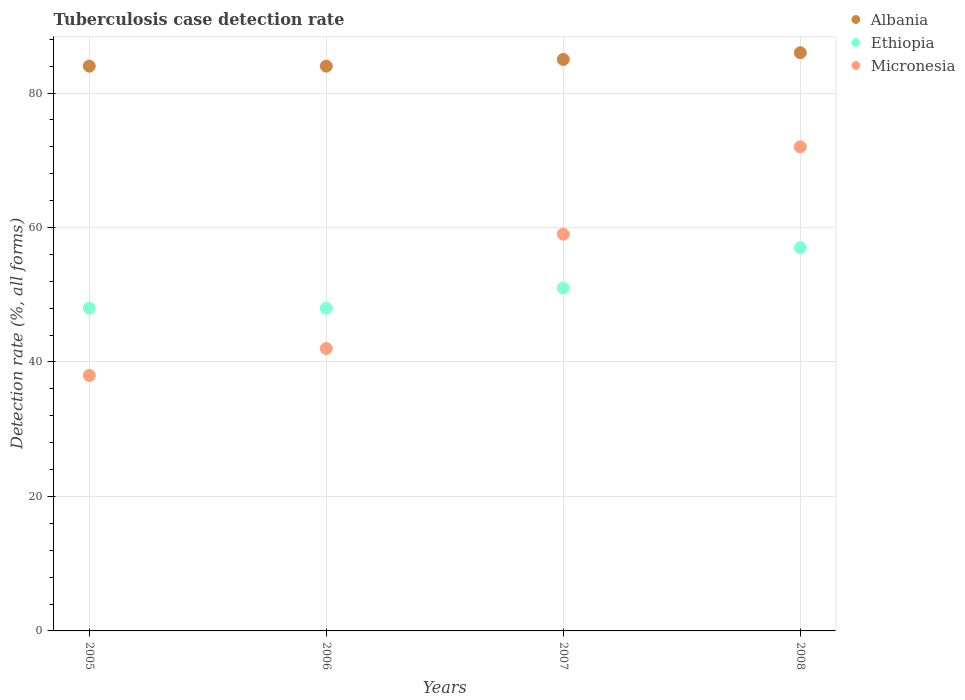What is the tuberculosis case detection rate in in Ethiopia in 2007?
Keep it short and to the point. 51. Across all years, what is the maximum tuberculosis case detection rate in in Albania?
Keep it short and to the point. 86. Across all years, what is the minimum tuberculosis case detection rate in in Ethiopia?
Your answer should be very brief. 48. In which year was the tuberculosis case detection rate in in Albania maximum?
Offer a very short reply. 2008. What is the total tuberculosis case detection rate in in Ethiopia in the graph?
Offer a very short reply. 204. What is the difference between the tuberculosis case detection rate in in Albania in 2007 and that in 2008?
Offer a terse response. -1. What is the difference between the tuberculosis case detection rate in in Micronesia in 2006 and the tuberculosis case detection rate in in Ethiopia in 2005?
Offer a terse response. -6. What is the average tuberculosis case detection rate in in Micronesia per year?
Ensure brevity in your answer.  52.75. In the year 2006, what is the difference between the tuberculosis case detection rate in in Albania and tuberculosis case detection rate in in Ethiopia?
Your answer should be compact. 36. What is the ratio of the tuberculosis case detection rate in in Ethiopia in 2005 to that in 2008?
Your response must be concise. 0.84. Is the tuberculosis case detection rate in in Micronesia in 2005 less than that in 2007?
Make the answer very short. Yes. Is the sum of the tuberculosis case detection rate in in Albania in 2005 and 2007 greater than the maximum tuberculosis case detection rate in in Micronesia across all years?
Provide a short and direct response. Yes. Is the tuberculosis case detection rate in in Albania strictly less than the tuberculosis case detection rate in in Ethiopia over the years?
Give a very brief answer. No. How many dotlines are there?
Your response must be concise. 3. How many years are there in the graph?
Keep it short and to the point. 4. Does the graph contain any zero values?
Provide a succinct answer. No. Where does the legend appear in the graph?
Your answer should be compact. Top right. How many legend labels are there?
Give a very brief answer. 3. How are the legend labels stacked?
Offer a terse response. Vertical. What is the title of the graph?
Make the answer very short. Tuberculosis case detection rate. What is the label or title of the X-axis?
Provide a succinct answer. Years. What is the label or title of the Y-axis?
Ensure brevity in your answer.  Detection rate (%, all forms). What is the Detection rate (%, all forms) in Albania in 2005?
Provide a succinct answer. 84. What is the Detection rate (%, all forms) in Albania in 2006?
Your answer should be compact. 84. What is the Detection rate (%, all forms) in Ethiopia in 2006?
Offer a very short reply. 48. What is the Detection rate (%, all forms) of Albania in 2007?
Give a very brief answer. 85. What is the Detection rate (%, all forms) in Albania in 2008?
Provide a succinct answer. 86. What is the Detection rate (%, all forms) of Micronesia in 2008?
Make the answer very short. 72. Across all years, what is the maximum Detection rate (%, all forms) in Albania?
Provide a succinct answer. 86. Across all years, what is the maximum Detection rate (%, all forms) in Ethiopia?
Give a very brief answer. 57. Across all years, what is the maximum Detection rate (%, all forms) of Micronesia?
Provide a succinct answer. 72. Across all years, what is the minimum Detection rate (%, all forms) in Ethiopia?
Give a very brief answer. 48. Across all years, what is the minimum Detection rate (%, all forms) in Micronesia?
Provide a succinct answer. 38. What is the total Detection rate (%, all forms) of Albania in the graph?
Your answer should be compact. 339. What is the total Detection rate (%, all forms) in Ethiopia in the graph?
Your response must be concise. 204. What is the total Detection rate (%, all forms) of Micronesia in the graph?
Your answer should be very brief. 211. What is the difference between the Detection rate (%, all forms) of Ethiopia in 2005 and that in 2006?
Offer a terse response. 0. What is the difference between the Detection rate (%, all forms) in Albania in 2005 and that in 2007?
Offer a terse response. -1. What is the difference between the Detection rate (%, all forms) in Ethiopia in 2005 and that in 2007?
Give a very brief answer. -3. What is the difference between the Detection rate (%, all forms) in Micronesia in 2005 and that in 2007?
Give a very brief answer. -21. What is the difference between the Detection rate (%, all forms) in Albania in 2005 and that in 2008?
Provide a succinct answer. -2. What is the difference between the Detection rate (%, all forms) of Micronesia in 2005 and that in 2008?
Make the answer very short. -34. What is the difference between the Detection rate (%, all forms) of Ethiopia in 2006 and that in 2007?
Keep it short and to the point. -3. What is the difference between the Detection rate (%, all forms) of Micronesia in 2006 and that in 2007?
Your answer should be very brief. -17. What is the difference between the Detection rate (%, all forms) in Albania in 2006 and that in 2008?
Offer a terse response. -2. What is the difference between the Detection rate (%, all forms) in Ethiopia in 2006 and that in 2008?
Ensure brevity in your answer.  -9. What is the difference between the Detection rate (%, all forms) of Micronesia in 2006 and that in 2008?
Keep it short and to the point. -30. What is the difference between the Detection rate (%, all forms) of Albania in 2007 and that in 2008?
Ensure brevity in your answer.  -1. What is the difference between the Detection rate (%, all forms) in Micronesia in 2007 and that in 2008?
Offer a terse response. -13. What is the difference between the Detection rate (%, all forms) of Albania in 2005 and the Detection rate (%, all forms) of Ethiopia in 2006?
Your response must be concise. 36. What is the difference between the Detection rate (%, all forms) of Ethiopia in 2005 and the Detection rate (%, all forms) of Micronesia in 2006?
Make the answer very short. 6. What is the difference between the Detection rate (%, all forms) of Albania in 2005 and the Detection rate (%, all forms) of Micronesia in 2007?
Provide a succinct answer. 25. What is the difference between the Detection rate (%, all forms) in Ethiopia in 2005 and the Detection rate (%, all forms) in Micronesia in 2007?
Provide a short and direct response. -11. What is the difference between the Detection rate (%, all forms) in Albania in 2005 and the Detection rate (%, all forms) in Micronesia in 2008?
Your response must be concise. 12. What is the difference between the Detection rate (%, all forms) of Ethiopia in 2005 and the Detection rate (%, all forms) of Micronesia in 2008?
Offer a terse response. -24. What is the difference between the Detection rate (%, all forms) in Albania in 2006 and the Detection rate (%, all forms) in Micronesia in 2007?
Keep it short and to the point. 25. What is the difference between the Detection rate (%, all forms) of Ethiopia in 2006 and the Detection rate (%, all forms) of Micronesia in 2007?
Offer a very short reply. -11. What is the difference between the Detection rate (%, all forms) of Albania in 2006 and the Detection rate (%, all forms) of Ethiopia in 2008?
Keep it short and to the point. 27. What is the difference between the Detection rate (%, all forms) of Ethiopia in 2006 and the Detection rate (%, all forms) of Micronesia in 2008?
Your answer should be compact. -24. What is the average Detection rate (%, all forms) in Albania per year?
Your answer should be compact. 84.75. What is the average Detection rate (%, all forms) in Ethiopia per year?
Make the answer very short. 51. What is the average Detection rate (%, all forms) of Micronesia per year?
Make the answer very short. 52.75. In the year 2005, what is the difference between the Detection rate (%, all forms) of Albania and Detection rate (%, all forms) of Ethiopia?
Your answer should be compact. 36. In the year 2005, what is the difference between the Detection rate (%, all forms) of Albania and Detection rate (%, all forms) of Micronesia?
Keep it short and to the point. 46. In the year 2006, what is the difference between the Detection rate (%, all forms) of Albania and Detection rate (%, all forms) of Micronesia?
Ensure brevity in your answer.  42. In the year 2007, what is the difference between the Detection rate (%, all forms) in Albania and Detection rate (%, all forms) in Micronesia?
Provide a short and direct response. 26. In the year 2008, what is the difference between the Detection rate (%, all forms) in Albania and Detection rate (%, all forms) in Ethiopia?
Give a very brief answer. 29. In the year 2008, what is the difference between the Detection rate (%, all forms) of Albania and Detection rate (%, all forms) of Micronesia?
Give a very brief answer. 14. In the year 2008, what is the difference between the Detection rate (%, all forms) of Ethiopia and Detection rate (%, all forms) of Micronesia?
Your response must be concise. -15. What is the ratio of the Detection rate (%, all forms) of Albania in 2005 to that in 2006?
Your answer should be very brief. 1. What is the ratio of the Detection rate (%, all forms) of Micronesia in 2005 to that in 2006?
Provide a succinct answer. 0.9. What is the ratio of the Detection rate (%, all forms) in Ethiopia in 2005 to that in 2007?
Give a very brief answer. 0.94. What is the ratio of the Detection rate (%, all forms) in Micronesia in 2005 to that in 2007?
Ensure brevity in your answer.  0.64. What is the ratio of the Detection rate (%, all forms) in Albania in 2005 to that in 2008?
Keep it short and to the point. 0.98. What is the ratio of the Detection rate (%, all forms) in Ethiopia in 2005 to that in 2008?
Give a very brief answer. 0.84. What is the ratio of the Detection rate (%, all forms) in Micronesia in 2005 to that in 2008?
Keep it short and to the point. 0.53. What is the ratio of the Detection rate (%, all forms) in Ethiopia in 2006 to that in 2007?
Provide a short and direct response. 0.94. What is the ratio of the Detection rate (%, all forms) in Micronesia in 2006 to that in 2007?
Ensure brevity in your answer.  0.71. What is the ratio of the Detection rate (%, all forms) in Albania in 2006 to that in 2008?
Ensure brevity in your answer.  0.98. What is the ratio of the Detection rate (%, all forms) of Ethiopia in 2006 to that in 2008?
Offer a very short reply. 0.84. What is the ratio of the Detection rate (%, all forms) of Micronesia in 2006 to that in 2008?
Your answer should be very brief. 0.58. What is the ratio of the Detection rate (%, all forms) in Albania in 2007 to that in 2008?
Your response must be concise. 0.99. What is the ratio of the Detection rate (%, all forms) of Ethiopia in 2007 to that in 2008?
Your response must be concise. 0.89. What is the ratio of the Detection rate (%, all forms) in Micronesia in 2007 to that in 2008?
Keep it short and to the point. 0.82. What is the difference between the highest and the second highest Detection rate (%, all forms) in Micronesia?
Offer a very short reply. 13. What is the difference between the highest and the lowest Detection rate (%, all forms) in Ethiopia?
Your answer should be compact. 9. What is the difference between the highest and the lowest Detection rate (%, all forms) in Micronesia?
Make the answer very short. 34. 